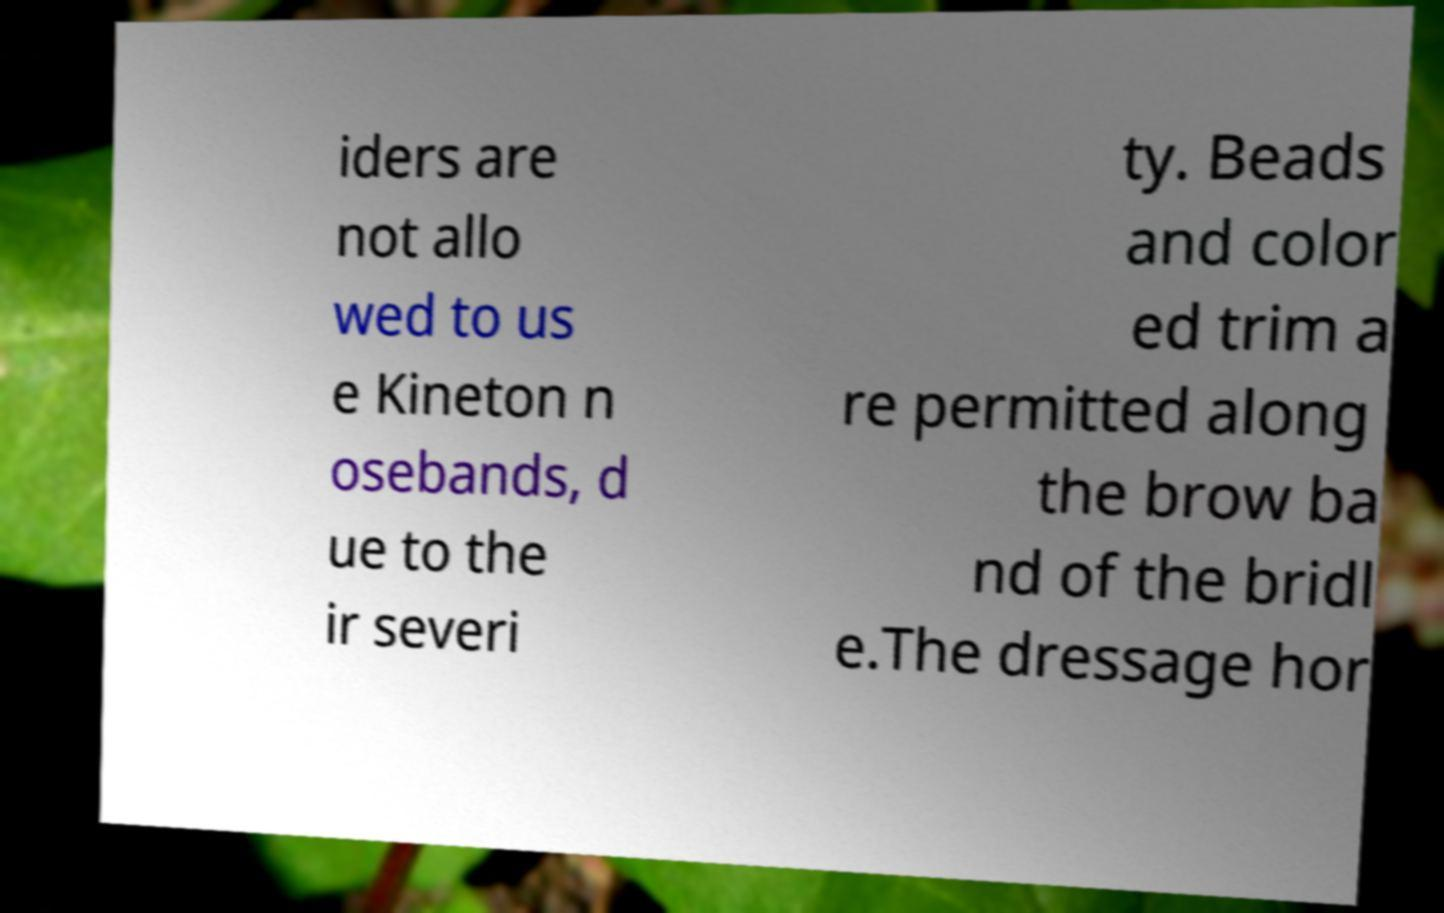Can you read and provide the text displayed in the image?This photo seems to have some interesting text. Can you extract and type it out for me? iders are not allo wed to us e Kineton n osebands, d ue to the ir severi ty. Beads and color ed trim a re permitted along the brow ba nd of the bridl e.The dressage hor 